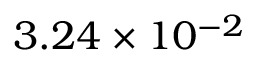Convert formula to latex. <formula><loc_0><loc_0><loc_500><loc_500>3 . 2 4 \times 1 0 ^ { - 2 }</formula> 